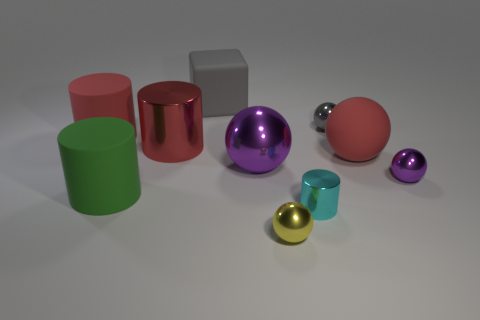Are there any other red cylinders that have the same material as the small cylinder?
Ensure brevity in your answer.  Yes. There is a large red thing that is behind the big shiny cylinder; what is its shape?
Keep it short and to the point. Cylinder. There is a metal cylinder behind the small cyan object; is it the same color as the block?
Ensure brevity in your answer.  No. Is the number of gray rubber objects to the right of the yellow metallic thing less than the number of large purple spheres?
Offer a terse response. Yes. The large block that is made of the same material as the large green cylinder is what color?
Provide a succinct answer. Gray. There is a ball that is in front of the cyan metallic cylinder; what is its size?
Offer a terse response. Small. Is the material of the red ball the same as the large purple object?
Your response must be concise. No. There is a large purple metal sphere in front of the big red thing that is in front of the big red metallic thing; are there any large rubber objects behind it?
Make the answer very short. Yes. The large rubber sphere has what color?
Ensure brevity in your answer.  Red. The shiny cylinder that is the same size as the yellow metallic thing is what color?
Make the answer very short. Cyan. 